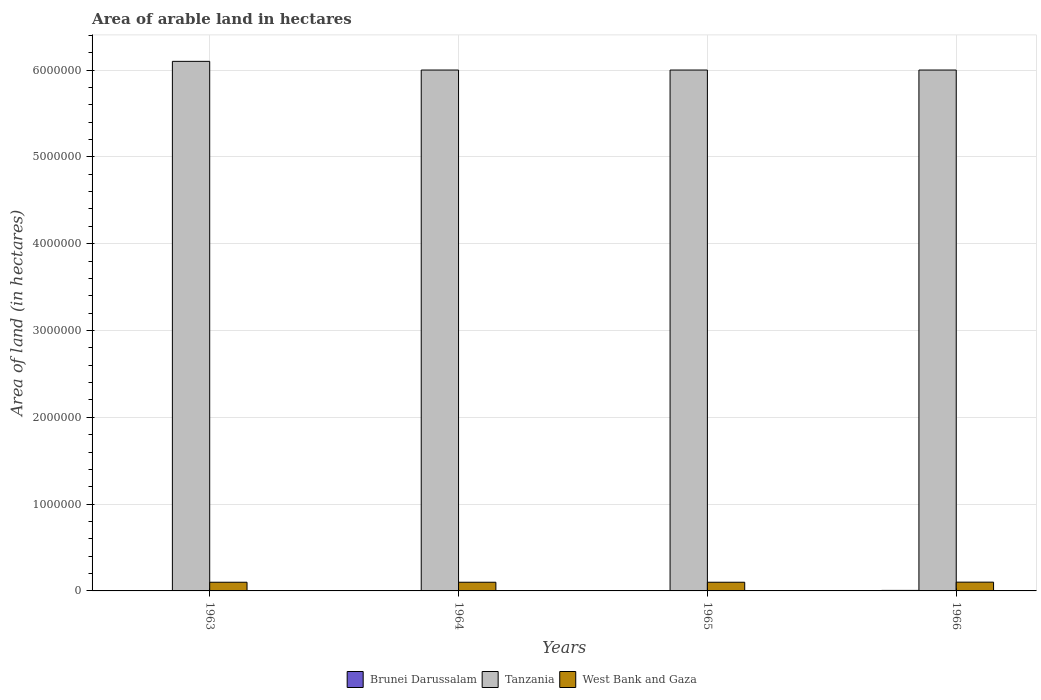Are the number of bars per tick equal to the number of legend labels?
Keep it short and to the point. Yes. What is the label of the 4th group of bars from the left?
Make the answer very short. 1966. What is the total arable land in West Bank and Gaza in 1965?
Your response must be concise. 1.00e+05. Across all years, what is the maximum total arable land in West Bank and Gaza?
Your response must be concise. 1.01e+05. Across all years, what is the minimum total arable land in Brunei Darussalam?
Make the answer very short. 4000. In which year was the total arable land in West Bank and Gaza maximum?
Provide a short and direct response. 1966. In which year was the total arable land in Tanzania minimum?
Make the answer very short. 1964. What is the total total arable land in Tanzania in the graph?
Offer a terse response. 2.41e+07. What is the difference between the total arable land in West Bank and Gaza in 1966 and the total arable land in Brunei Darussalam in 1963?
Provide a succinct answer. 9.70e+04. What is the average total arable land in Tanzania per year?
Offer a very short reply. 6.02e+06. In the year 1964, what is the difference between the total arable land in Brunei Darussalam and total arable land in West Bank and Gaza?
Provide a short and direct response. -9.60e+04. In how many years, is the total arable land in Brunei Darussalam greater than 1200000 hectares?
Offer a very short reply. 0. In how many years, is the total arable land in Brunei Darussalam greater than the average total arable land in Brunei Darussalam taken over all years?
Give a very brief answer. 1. Is the sum of the total arable land in Brunei Darussalam in 1963 and 1966 greater than the maximum total arable land in West Bank and Gaza across all years?
Keep it short and to the point. No. What does the 1st bar from the left in 1964 represents?
Offer a terse response. Brunei Darussalam. What does the 1st bar from the right in 1964 represents?
Offer a terse response. West Bank and Gaza. Is it the case that in every year, the sum of the total arable land in West Bank and Gaza and total arable land in Tanzania is greater than the total arable land in Brunei Darussalam?
Offer a very short reply. Yes. How many years are there in the graph?
Offer a terse response. 4. What is the difference between two consecutive major ticks on the Y-axis?
Provide a succinct answer. 1.00e+06. Does the graph contain any zero values?
Provide a succinct answer. No. Does the graph contain grids?
Ensure brevity in your answer.  Yes. Where does the legend appear in the graph?
Your response must be concise. Bottom center. How many legend labels are there?
Keep it short and to the point. 3. What is the title of the graph?
Provide a succinct answer. Area of arable land in hectares. Does "Least developed countries" appear as one of the legend labels in the graph?
Ensure brevity in your answer.  No. What is the label or title of the X-axis?
Your response must be concise. Years. What is the label or title of the Y-axis?
Provide a short and direct response. Area of land (in hectares). What is the Area of land (in hectares) of Brunei Darussalam in 1963?
Make the answer very short. 4000. What is the Area of land (in hectares) in Tanzania in 1963?
Your response must be concise. 6.10e+06. What is the Area of land (in hectares) of Brunei Darussalam in 1964?
Offer a very short reply. 4000. What is the Area of land (in hectares) in West Bank and Gaza in 1964?
Offer a terse response. 1.00e+05. What is the Area of land (in hectares) in Brunei Darussalam in 1965?
Provide a short and direct response. 4000. What is the Area of land (in hectares) in Tanzania in 1965?
Provide a short and direct response. 6.00e+06. What is the Area of land (in hectares) of West Bank and Gaza in 1965?
Give a very brief answer. 1.00e+05. What is the Area of land (in hectares) in Brunei Darussalam in 1966?
Ensure brevity in your answer.  6000. What is the Area of land (in hectares) in Tanzania in 1966?
Ensure brevity in your answer.  6.00e+06. What is the Area of land (in hectares) in West Bank and Gaza in 1966?
Your answer should be very brief. 1.01e+05. Across all years, what is the maximum Area of land (in hectares) of Brunei Darussalam?
Offer a terse response. 6000. Across all years, what is the maximum Area of land (in hectares) of Tanzania?
Provide a short and direct response. 6.10e+06. Across all years, what is the maximum Area of land (in hectares) of West Bank and Gaza?
Your answer should be compact. 1.01e+05. Across all years, what is the minimum Area of land (in hectares) in Brunei Darussalam?
Keep it short and to the point. 4000. Across all years, what is the minimum Area of land (in hectares) in Tanzania?
Your answer should be very brief. 6.00e+06. Across all years, what is the minimum Area of land (in hectares) of West Bank and Gaza?
Provide a short and direct response. 1.00e+05. What is the total Area of land (in hectares) of Brunei Darussalam in the graph?
Offer a very short reply. 1.80e+04. What is the total Area of land (in hectares) of Tanzania in the graph?
Make the answer very short. 2.41e+07. What is the total Area of land (in hectares) in West Bank and Gaza in the graph?
Provide a succinct answer. 4.01e+05. What is the difference between the Area of land (in hectares) of Brunei Darussalam in 1963 and that in 1964?
Keep it short and to the point. 0. What is the difference between the Area of land (in hectares) of Tanzania in 1963 and that in 1964?
Give a very brief answer. 1.00e+05. What is the difference between the Area of land (in hectares) in West Bank and Gaza in 1963 and that in 1964?
Provide a short and direct response. 0. What is the difference between the Area of land (in hectares) in Brunei Darussalam in 1963 and that in 1965?
Make the answer very short. 0. What is the difference between the Area of land (in hectares) in Tanzania in 1963 and that in 1965?
Make the answer very short. 1.00e+05. What is the difference between the Area of land (in hectares) in West Bank and Gaza in 1963 and that in 1965?
Offer a very short reply. 0. What is the difference between the Area of land (in hectares) in Brunei Darussalam in 1963 and that in 1966?
Offer a very short reply. -2000. What is the difference between the Area of land (in hectares) in West Bank and Gaza in 1963 and that in 1966?
Your response must be concise. -1000. What is the difference between the Area of land (in hectares) of West Bank and Gaza in 1964 and that in 1965?
Offer a very short reply. 0. What is the difference between the Area of land (in hectares) of Brunei Darussalam in 1964 and that in 1966?
Offer a terse response. -2000. What is the difference between the Area of land (in hectares) in West Bank and Gaza in 1964 and that in 1966?
Provide a succinct answer. -1000. What is the difference between the Area of land (in hectares) of Brunei Darussalam in 1965 and that in 1966?
Offer a very short reply. -2000. What is the difference between the Area of land (in hectares) in West Bank and Gaza in 1965 and that in 1966?
Offer a very short reply. -1000. What is the difference between the Area of land (in hectares) of Brunei Darussalam in 1963 and the Area of land (in hectares) of Tanzania in 1964?
Your response must be concise. -6.00e+06. What is the difference between the Area of land (in hectares) of Brunei Darussalam in 1963 and the Area of land (in hectares) of West Bank and Gaza in 1964?
Offer a terse response. -9.60e+04. What is the difference between the Area of land (in hectares) in Tanzania in 1963 and the Area of land (in hectares) in West Bank and Gaza in 1964?
Give a very brief answer. 6.00e+06. What is the difference between the Area of land (in hectares) of Brunei Darussalam in 1963 and the Area of land (in hectares) of Tanzania in 1965?
Your answer should be very brief. -6.00e+06. What is the difference between the Area of land (in hectares) in Brunei Darussalam in 1963 and the Area of land (in hectares) in West Bank and Gaza in 1965?
Offer a very short reply. -9.60e+04. What is the difference between the Area of land (in hectares) in Brunei Darussalam in 1963 and the Area of land (in hectares) in Tanzania in 1966?
Keep it short and to the point. -6.00e+06. What is the difference between the Area of land (in hectares) in Brunei Darussalam in 1963 and the Area of land (in hectares) in West Bank and Gaza in 1966?
Keep it short and to the point. -9.70e+04. What is the difference between the Area of land (in hectares) of Tanzania in 1963 and the Area of land (in hectares) of West Bank and Gaza in 1966?
Your answer should be very brief. 6.00e+06. What is the difference between the Area of land (in hectares) of Brunei Darussalam in 1964 and the Area of land (in hectares) of Tanzania in 1965?
Ensure brevity in your answer.  -6.00e+06. What is the difference between the Area of land (in hectares) in Brunei Darussalam in 1964 and the Area of land (in hectares) in West Bank and Gaza in 1965?
Give a very brief answer. -9.60e+04. What is the difference between the Area of land (in hectares) in Tanzania in 1964 and the Area of land (in hectares) in West Bank and Gaza in 1965?
Your response must be concise. 5.90e+06. What is the difference between the Area of land (in hectares) in Brunei Darussalam in 1964 and the Area of land (in hectares) in Tanzania in 1966?
Keep it short and to the point. -6.00e+06. What is the difference between the Area of land (in hectares) of Brunei Darussalam in 1964 and the Area of land (in hectares) of West Bank and Gaza in 1966?
Keep it short and to the point. -9.70e+04. What is the difference between the Area of land (in hectares) of Tanzania in 1964 and the Area of land (in hectares) of West Bank and Gaza in 1966?
Your response must be concise. 5.90e+06. What is the difference between the Area of land (in hectares) in Brunei Darussalam in 1965 and the Area of land (in hectares) in Tanzania in 1966?
Your response must be concise. -6.00e+06. What is the difference between the Area of land (in hectares) in Brunei Darussalam in 1965 and the Area of land (in hectares) in West Bank and Gaza in 1966?
Offer a terse response. -9.70e+04. What is the difference between the Area of land (in hectares) of Tanzania in 1965 and the Area of land (in hectares) of West Bank and Gaza in 1966?
Your response must be concise. 5.90e+06. What is the average Area of land (in hectares) in Brunei Darussalam per year?
Keep it short and to the point. 4500. What is the average Area of land (in hectares) in Tanzania per year?
Your answer should be very brief. 6.02e+06. What is the average Area of land (in hectares) of West Bank and Gaza per year?
Offer a very short reply. 1.00e+05. In the year 1963, what is the difference between the Area of land (in hectares) of Brunei Darussalam and Area of land (in hectares) of Tanzania?
Your answer should be very brief. -6.10e+06. In the year 1963, what is the difference between the Area of land (in hectares) in Brunei Darussalam and Area of land (in hectares) in West Bank and Gaza?
Provide a short and direct response. -9.60e+04. In the year 1963, what is the difference between the Area of land (in hectares) of Tanzania and Area of land (in hectares) of West Bank and Gaza?
Offer a very short reply. 6.00e+06. In the year 1964, what is the difference between the Area of land (in hectares) of Brunei Darussalam and Area of land (in hectares) of Tanzania?
Your response must be concise. -6.00e+06. In the year 1964, what is the difference between the Area of land (in hectares) in Brunei Darussalam and Area of land (in hectares) in West Bank and Gaza?
Provide a short and direct response. -9.60e+04. In the year 1964, what is the difference between the Area of land (in hectares) of Tanzania and Area of land (in hectares) of West Bank and Gaza?
Give a very brief answer. 5.90e+06. In the year 1965, what is the difference between the Area of land (in hectares) in Brunei Darussalam and Area of land (in hectares) in Tanzania?
Your answer should be very brief. -6.00e+06. In the year 1965, what is the difference between the Area of land (in hectares) in Brunei Darussalam and Area of land (in hectares) in West Bank and Gaza?
Provide a short and direct response. -9.60e+04. In the year 1965, what is the difference between the Area of land (in hectares) of Tanzania and Area of land (in hectares) of West Bank and Gaza?
Ensure brevity in your answer.  5.90e+06. In the year 1966, what is the difference between the Area of land (in hectares) of Brunei Darussalam and Area of land (in hectares) of Tanzania?
Offer a very short reply. -5.99e+06. In the year 1966, what is the difference between the Area of land (in hectares) in Brunei Darussalam and Area of land (in hectares) in West Bank and Gaza?
Provide a succinct answer. -9.50e+04. In the year 1966, what is the difference between the Area of land (in hectares) of Tanzania and Area of land (in hectares) of West Bank and Gaza?
Offer a very short reply. 5.90e+06. What is the ratio of the Area of land (in hectares) in Brunei Darussalam in 1963 to that in 1964?
Keep it short and to the point. 1. What is the ratio of the Area of land (in hectares) of Tanzania in 1963 to that in 1964?
Your answer should be compact. 1.02. What is the ratio of the Area of land (in hectares) in Brunei Darussalam in 1963 to that in 1965?
Your answer should be very brief. 1. What is the ratio of the Area of land (in hectares) in Tanzania in 1963 to that in 1965?
Offer a terse response. 1.02. What is the ratio of the Area of land (in hectares) of Brunei Darussalam in 1963 to that in 1966?
Provide a succinct answer. 0.67. What is the ratio of the Area of land (in hectares) in Tanzania in 1963 to that in 1966?
Keep it short and to the point. 1.02. What is the ratio of the Area of land (in hectares) of Tanzania in 1964 to that in 1965?
Your answer should be compact. 1. What is the ratio of the Area of land (in hectares) of Tanzania in 1964 to that in 1966?
Your answer should be very brief. 1. What is the ratio of the Area of land (in hectares) in West Bank and Gaza in 1964 to that in 1966?
Offer a terse response. 0.99. What is the ratio of the Area of land (in hectares) in Brunei Darussalam in 1965 to that in 1966?
Provide a succinct answer. 0.67. What is the difference between the highest and the second highest Area of land (in hectares) of Brunei Darussalam?
Your answer should be compact. 2000. What is the difference between the highest and the lowest Area of land (in hectares) of Brunei Darussalam?
Give a very brief answer. 2000. 